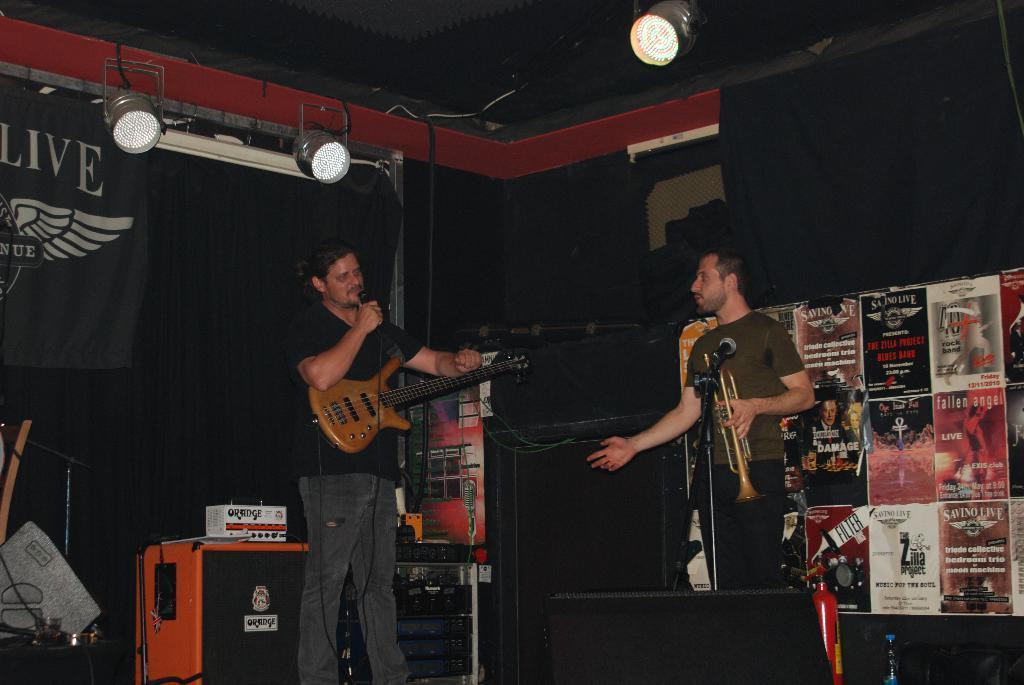Could you give a brief overview of what you see in this image? As we can see in the image there are lights, banner and two people. The man who is standing here is holding guitar in his hand and in front of him there is a mic 